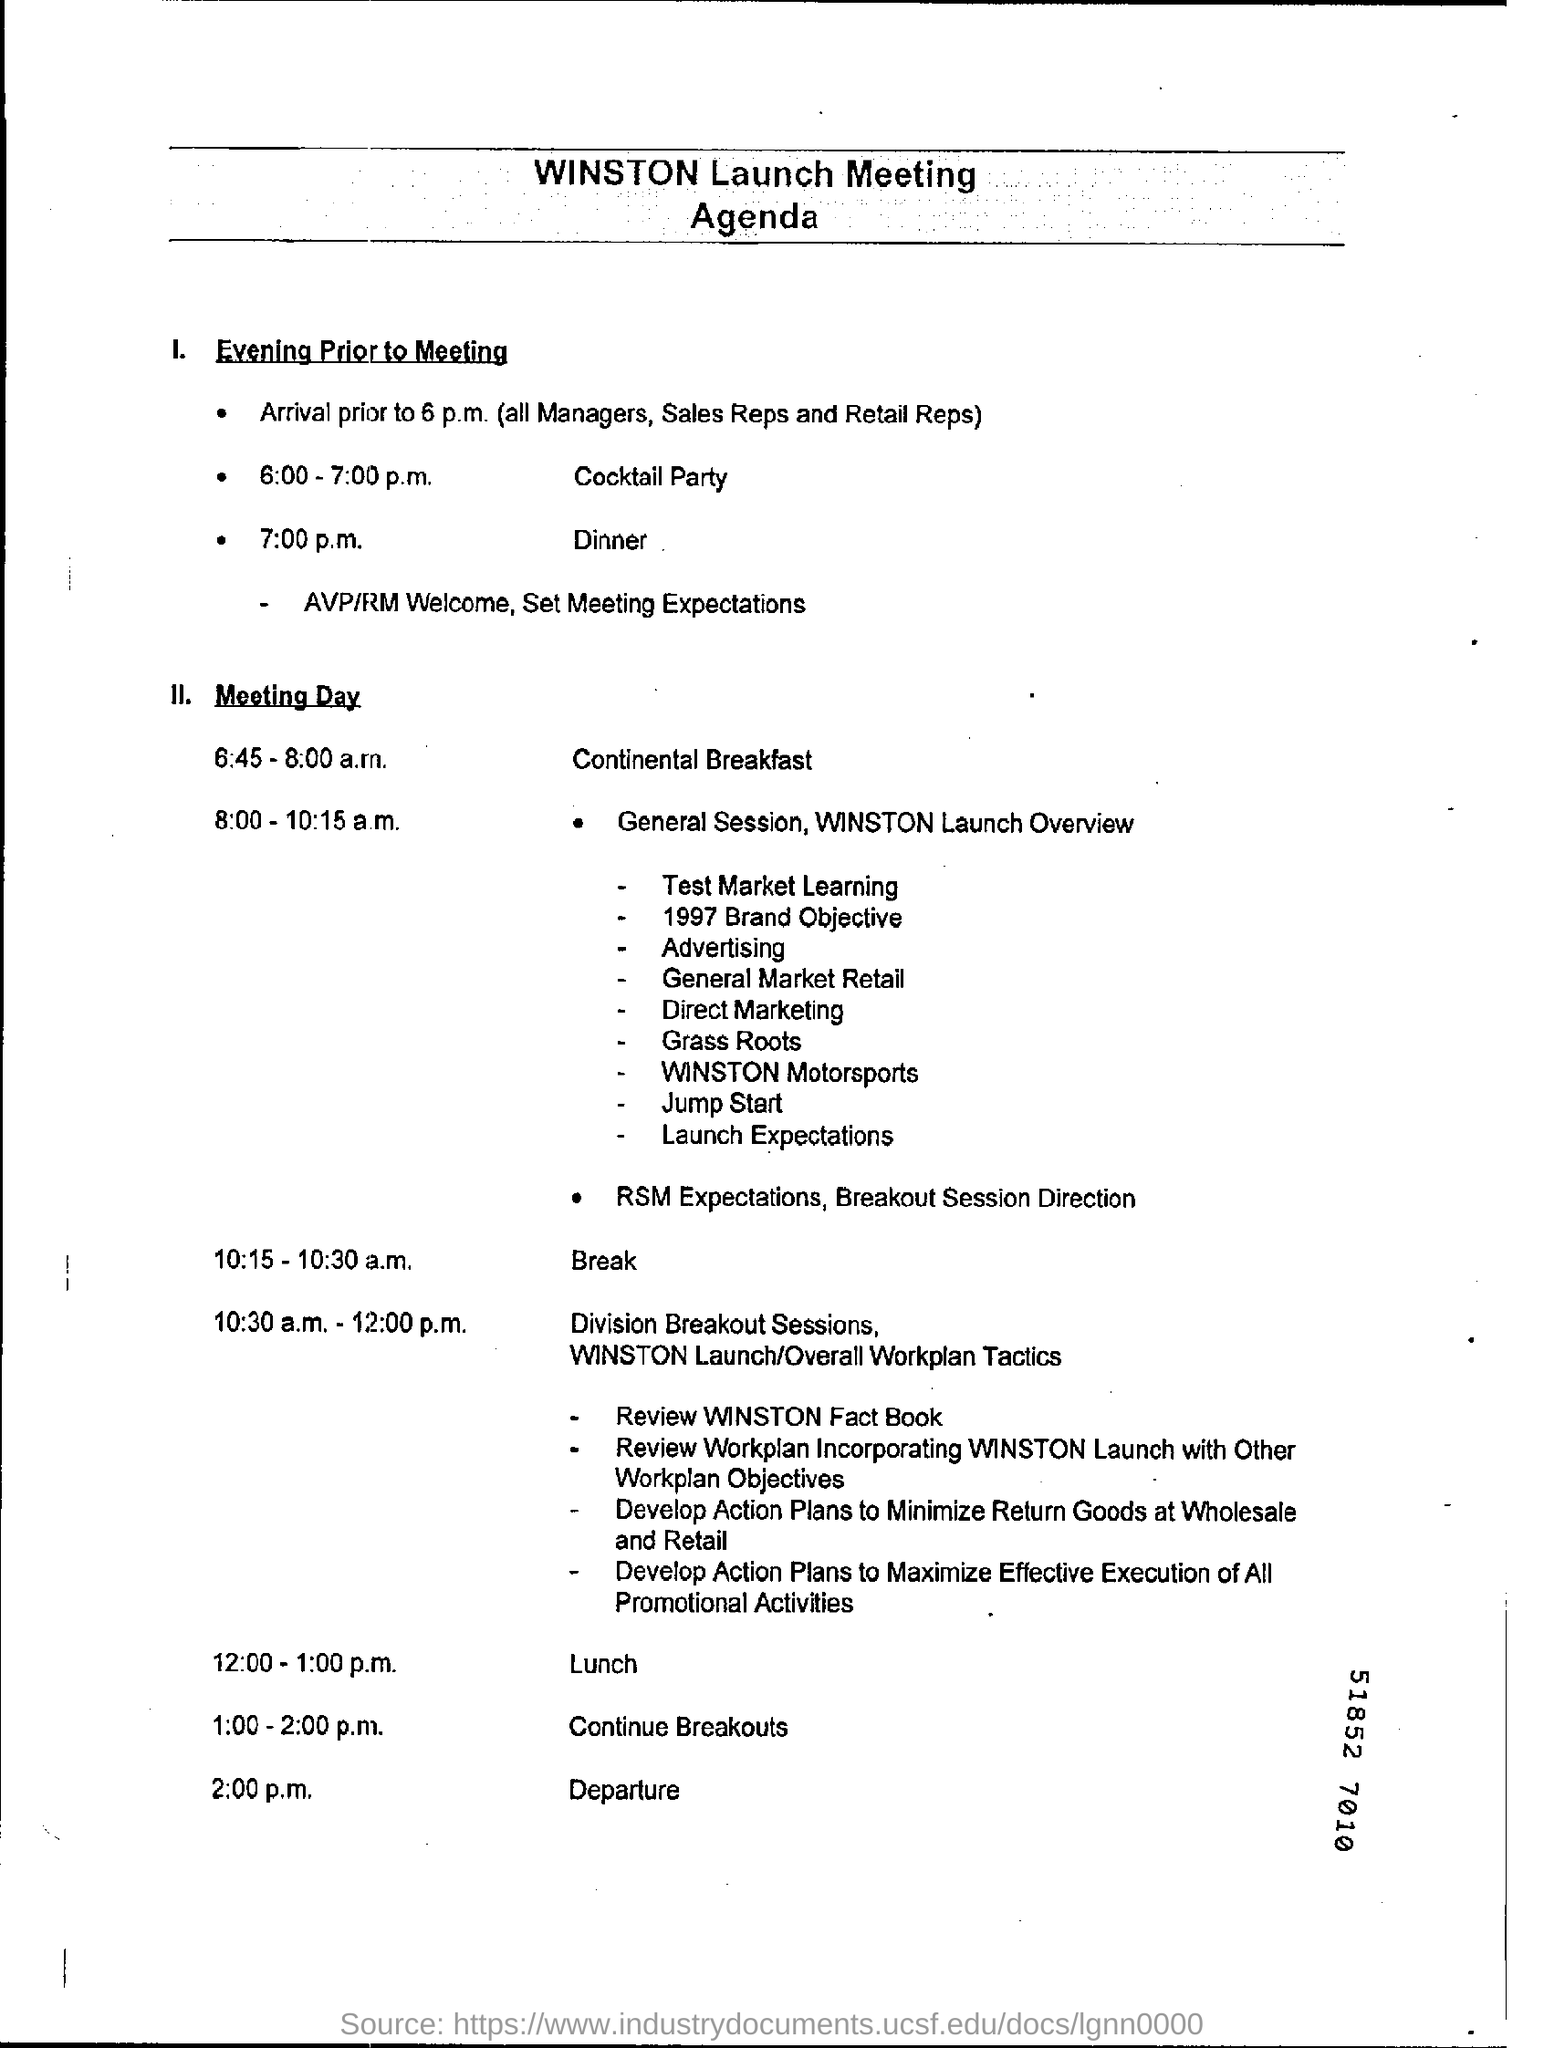Mention a couple of crucial points in this snapshot. The departure is scheduled for 2:00 p.m. The dinner on the day prior to the meeting will take place at 7:00 p.m. The agenda for the Winston launch meeting will focus on discussing the details and goals of the project. From 8:00-10:15 a.m., the General Session and the WINSTON Launch Overview are scheduled. The cocktail party is scheduled to take place between 6:00 and 7:00 p.m. the previous day of the meeting. 